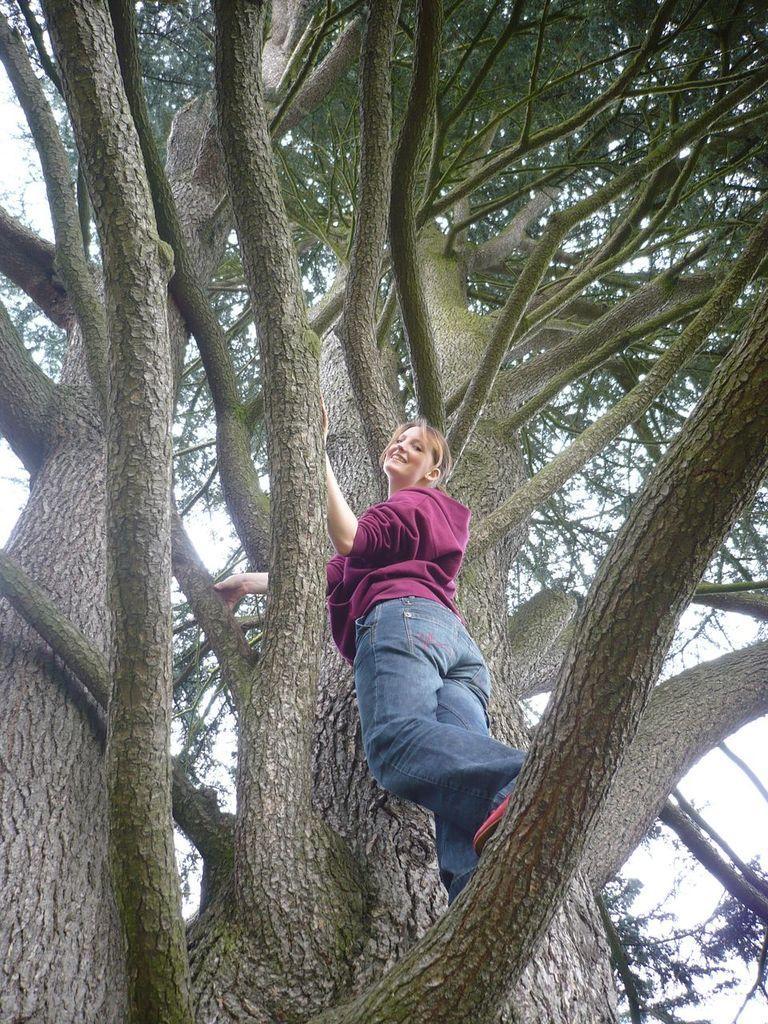In one or two sentences, can you explain what this image depicts? Here I can see a woman wearing a jacket, jeans, smiling and standing on a tree trunk. 